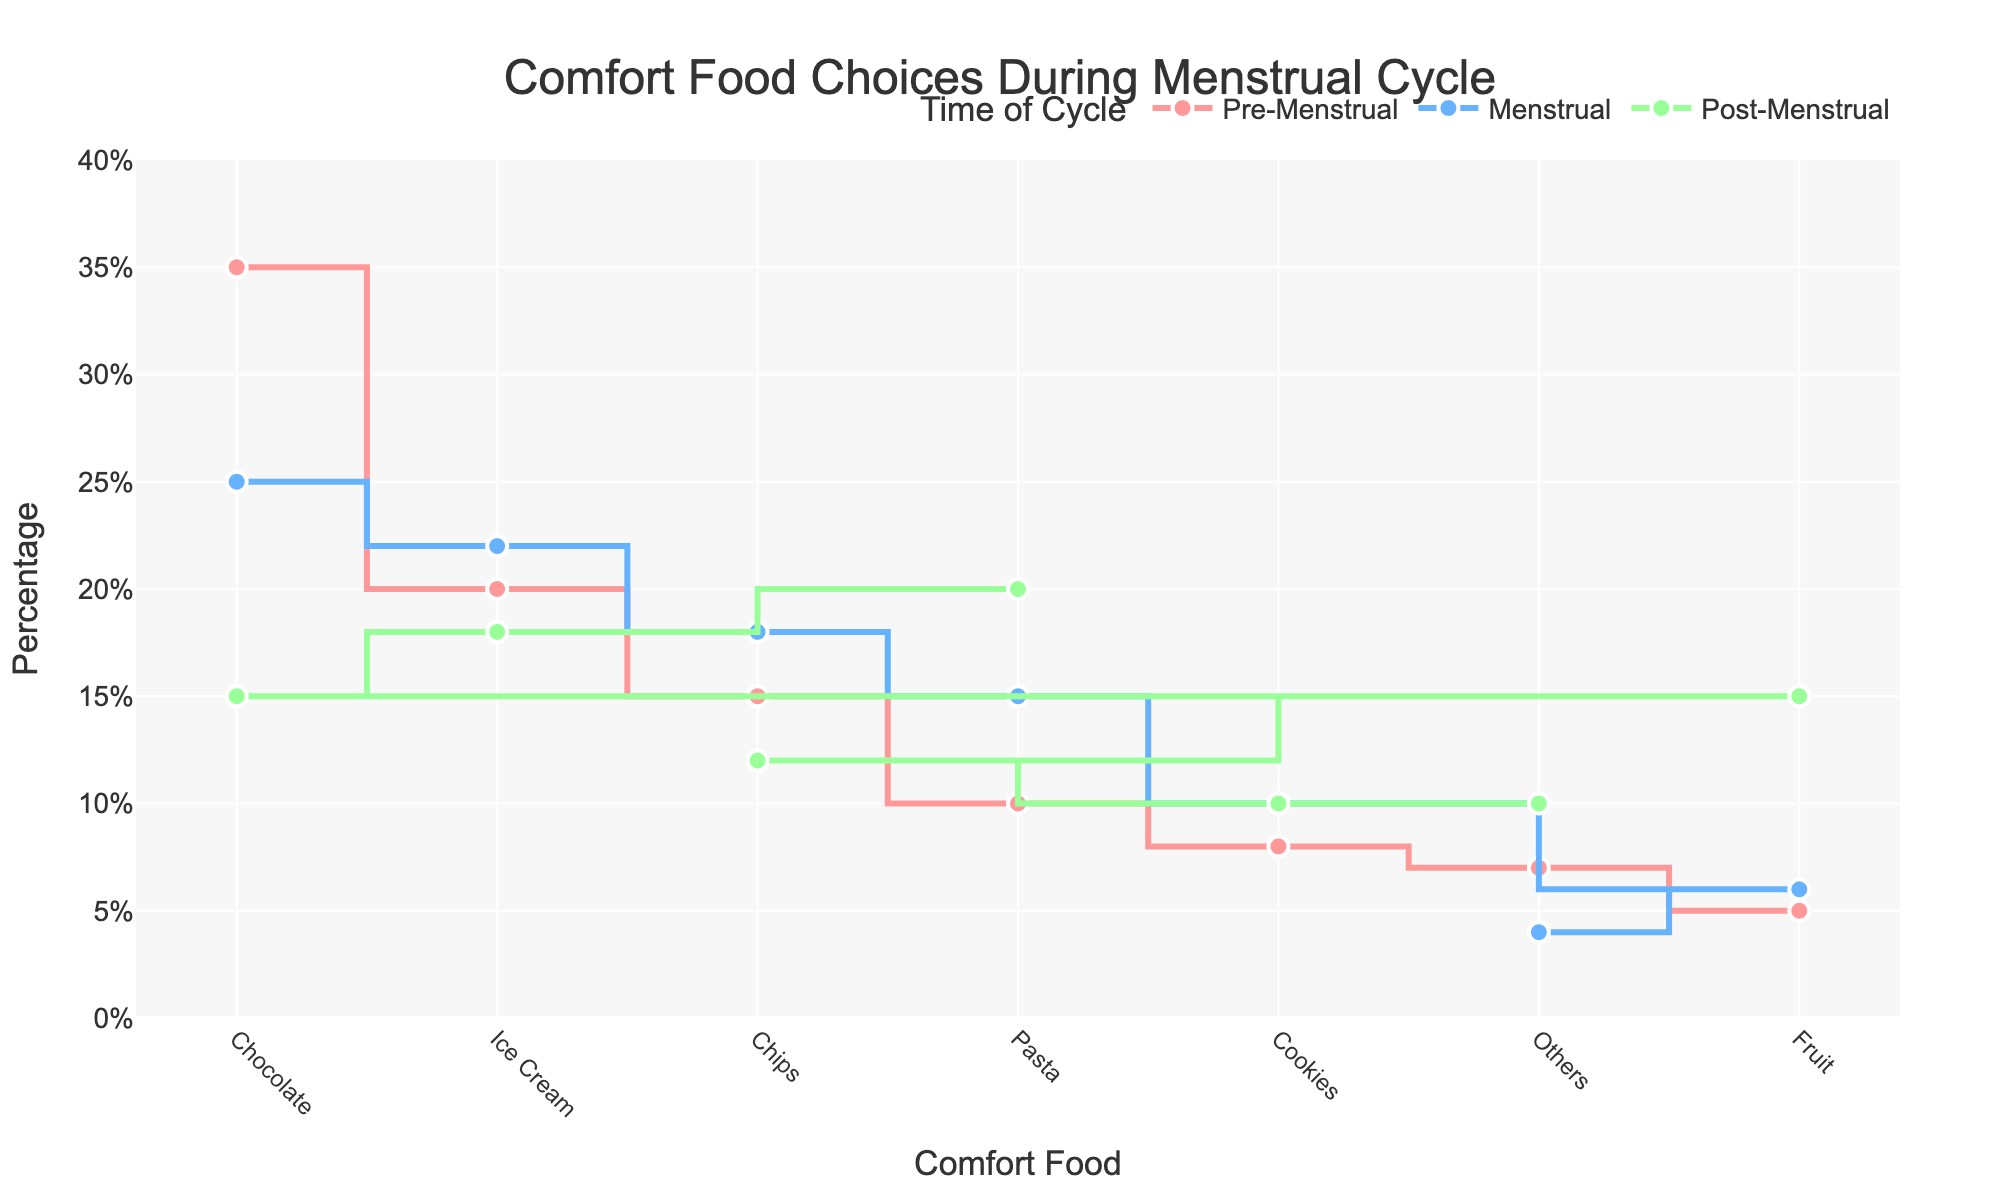Which comfort food has the highest percentage during the Pre-Menstrual phase? In the figure, the highest point on the Pre-Menstrual phase line represents the comfort food with the highest percentage. Chocolate shows the highest percentage.
Answer: Chocolate What is the percentage difference of chocolate consumption between Pre-Menstrual and Menstrual phases? The percentage for chocolate in the Pre-Menstrual phase is 35%, and for the Menstrual phase, it is 25%. The difference is calculated by subtracting the Menstrual percentage from the Pre-Menstrual percentage: 35% - 25% = 10%.
Answer: 10% During which phase is fruit consumption the highest? By observing the figure, the highest point for the fruit line is in the Post-Menstrual phase at 15%.
Answer: Post-Menstrual How does the preference for ice cream change across the phases? By tracking the line representing Ice Cream across the phases: it starts at 20% in the Pre-Menstrual phase, slightly increases to 22% during the Menstrual phase, and then slightly decreases to 18% in the Post-Menstrual phase.
Answer: It increases from Pre-Menstrual to Menstrual, then decreases in Post-Menstrual Compare the percentage of chips consumed during the Menstrual and Post-Menstrual phases. The figure shows chips consumption at 18% during Menstrual and 12% during Post-Menstrual. Therefore, chips are consumed more during the Menstrual phase.
Answer: Menstrual Which comfort food shows the least variation across different phases? By observing the variation in the lines for each comfort food across the phases, Cookies show the smallest changes in percentage, remaining close to 10% in each phase.
Answer: Cookies What is the total percentage of all other comfort foods consumed during the Pre-Menstrual phase? From the figure, the percentages are: Chips (15%), Pasta (10%), Cookies (8%), Fruit (5%), Others (7%). Sum these values: 15% + 10% + 8% + 5% + 7% = 45%.
Answer: 45% What is the average percentage for comfort food consumption during the Post-Menstrual phase? Sum all percentages for Post-Menstrual phase and divide by the number of food categories: (15 + 18 + 12 + 20 + 10 + 15 + 10)/7 = 100/7 ≈ 14.29%.
Answer: 14.29% How does chocolate consumption change from Pre-Menstrual to Post-Menstrual phases? Chocolate consumption decreases from 35% in the Pre-Menstrual phase to 15% in the Post-Menstrual phase, showing a clear downward trend.
Answer: It decreases What percentage of comfort food consumption is attributed to Others during the Menstrual phase? The figure shows the percentage for 'Others' during the Menstrual phase as 4%.
Answer: 4% 